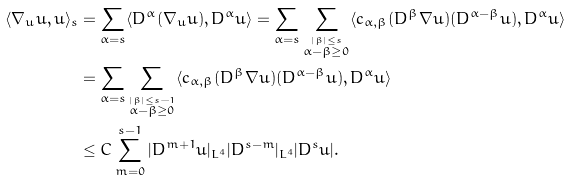Convert formula to latex. <formula><loc_0><loc_0><loc_500><loc_500>\langle \nabla _ { u } u , u \rangle _ { s } & = \sum _ { \alpha = s } \langle D ^ { \alpha } ( \nabla _ { u } u ) , D ^ { \alpha } u \rangle = \sum _ { \alpha = s } \sum _ { \stackrel { | \beta | \leq s } { \alpha - \beta \geq 0 } } \langle c _ { \alpha , \beta } ( D ^ { \beta } \nabla u ) ( D ^ { \alpha - \beta } u ) , D ^ { \alpha } u \rangle \\ & = \sum _ { \alpha = s } \sum _ { \stackrel { | \beta | \leq { s - 1 } } { \alpha - \beta \geq 0 } } \langle c _ { \alpha , \beta } ( D ^ { \beta } \nabla u ) ( D ^ { \alpha - \beta } u ) , D ^ { \alpha } u \rangle \\ & \leq C \sum _ { m = 0 } ^ { s - 1 } | D ^ { m + 1 } u | _ { L ^ { 4 } } | D ^ { s - m } | _ { L ^ { 4 } } | D ^ { s } u | .</formula> 